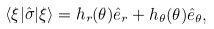<formula> <loc_0><loc_0><loc_500><loc_500>\langle \xi | { \hat { \sigma } } | \xi \rangle = h _ { r } ( \theta ) { \hat { e } } _ { r } + h _ { \theta } ( \theta ) { \hat { e } } _ { \theta } ,</formula> 